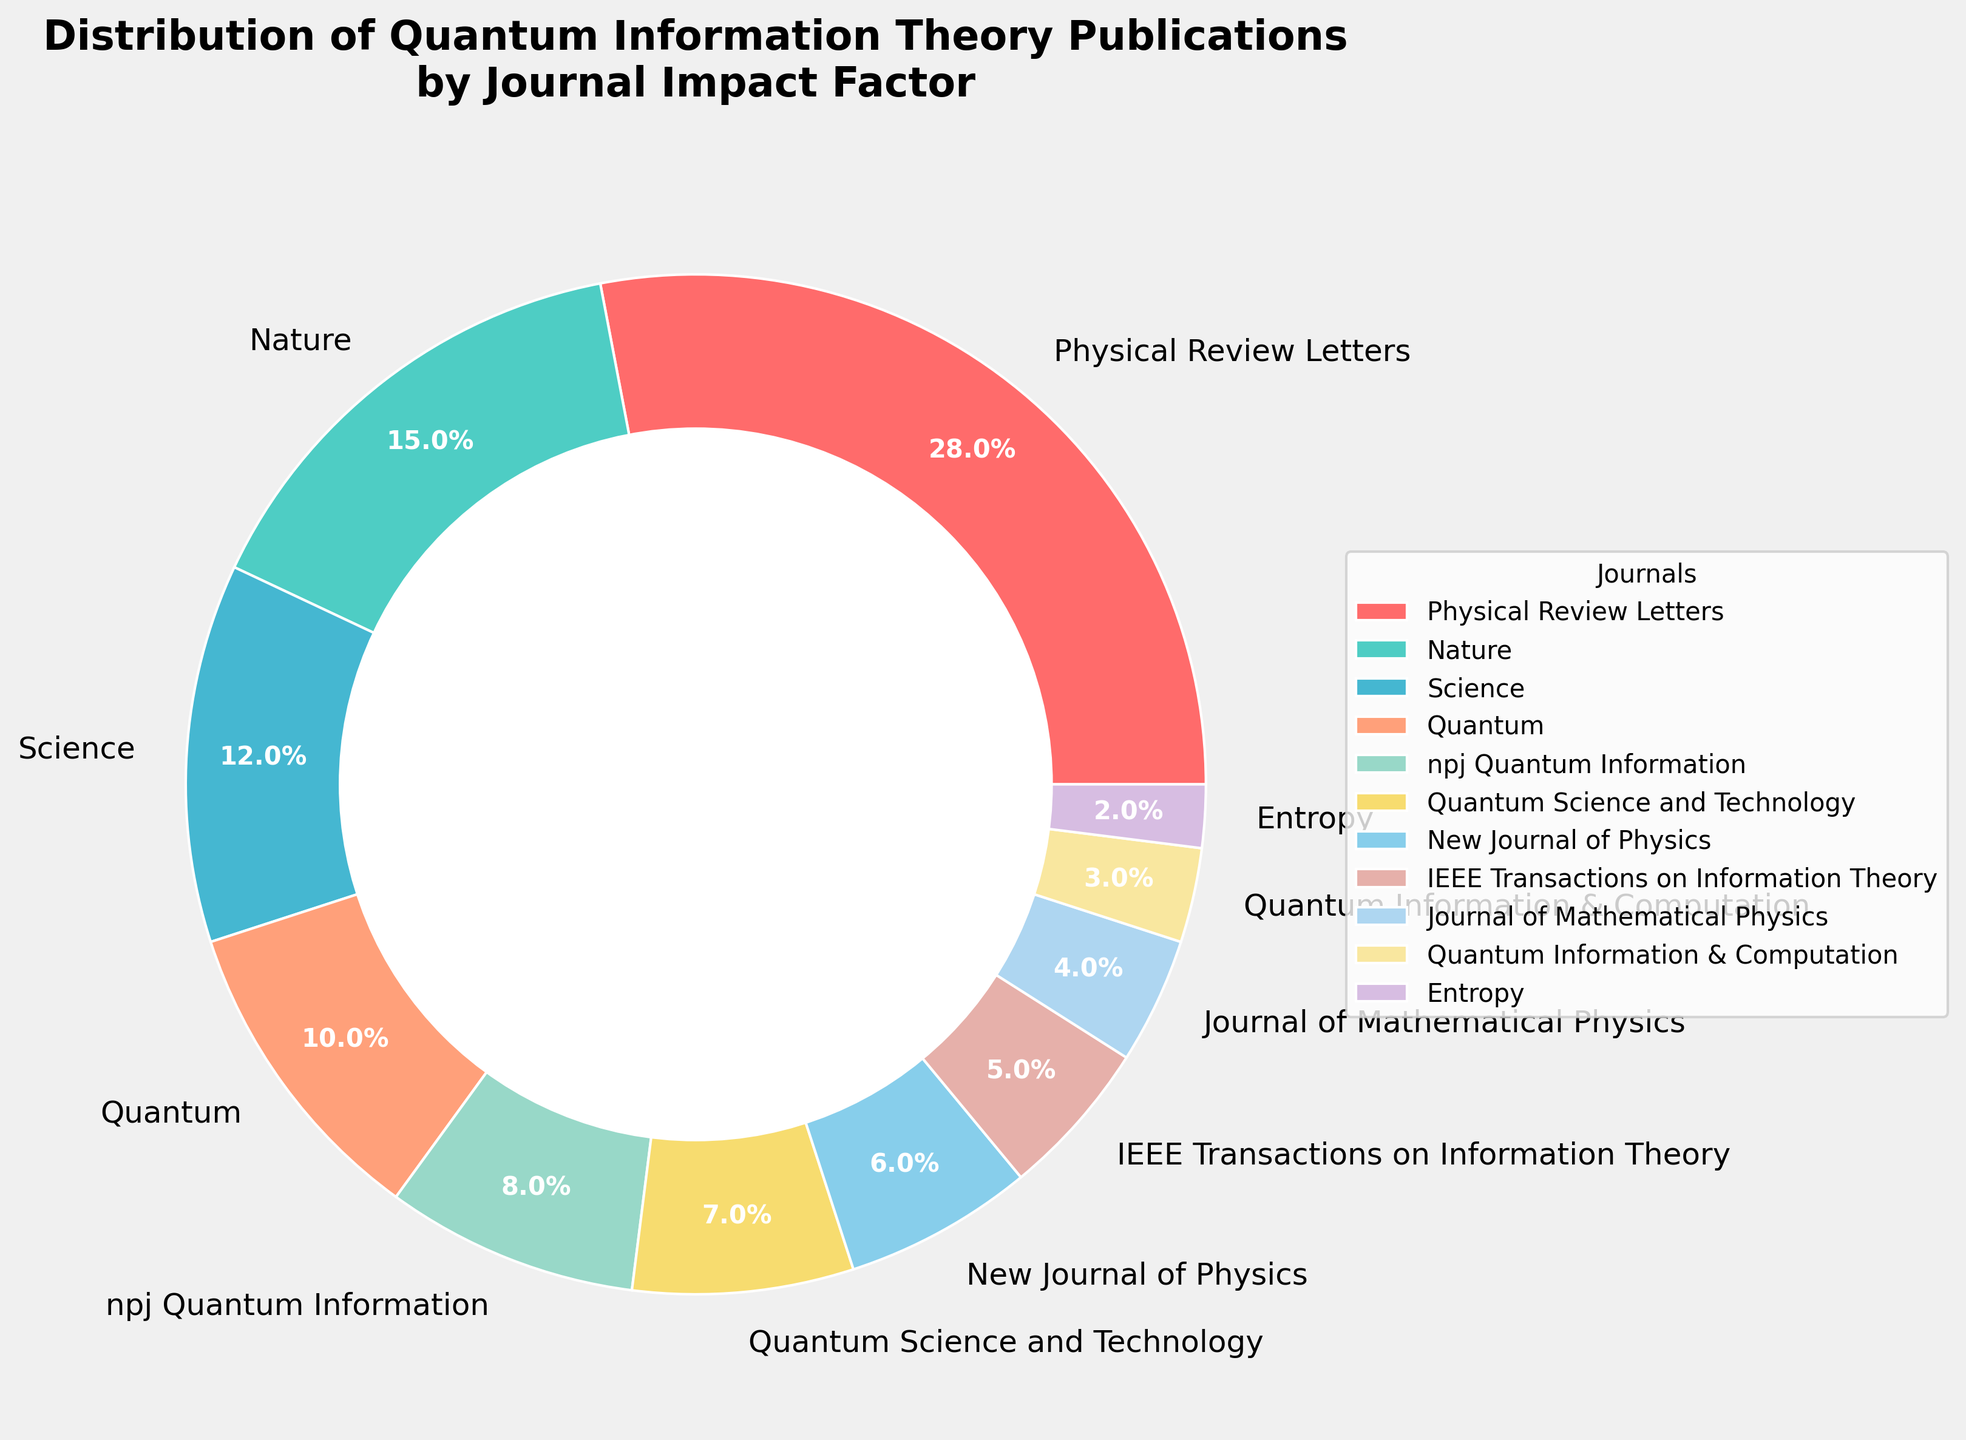What is the percentage of publications in the journal with the highest impact factor? The figure shows different journals and their associated publication percentages. "Physical Review Letters" has the largest slice, corresponding to 28%.
Answer: 28% What is the combined percentage of publications in "Nature" and "Science"? From the chart, "Nature" has 15% and "Science" has 12%. Summing them up gives 15% + 12% = 27%.
Answer: 27% Which journal has the smallest percentage of publications, and what is that percentage? The chart shows "Entropy" with the smallest slice, corresponding to 2%.
Answer: Entropy, 2% How much higher is the percentage of publications in "Physical Review Letters" compared to "Quantum"? "Physical Review Letters" has 28%, and "Quantum" has 10%. The difference is 28% - 10% = 18%.
Answer: 18% Is the percentage of publications in "npj Quantum Information" greater than or less than that in "Quantum"? "npj Quantum Information" has 8%, while "Quantum" has 10%. Therefore, it’s less.
Answer: less What is the total percentage of publications in journals with percentages less than 10% each? Adding up the percentages of "Quantum" (10%), "npj Quantum Information" (8%), "Quantum Science and Technology" (7%), "New Journal of Physics" (6%), "IEEE Transactions on Information Theory" (5%), "Journal of Mathematical Physics" (4%), "Quantum Information & Computation" (3%), "Entropy" (2%) gives: 10% + 8% + 7% + 6% + 5% + 4% + 3% + 2% = 45%.
Answer: 45% Which journal's percentage lies exactly between "Science" and "Quantum Science and Technology" when sorted in ascending order? Sorting the percentages in ascending order, "Quantum Science and Technology" has 7% and "Science" has 12%. The journal between them is "npj Quantum Information" with 8%.
Answer: npj Quantum Information What is the difference between the combined percentage of the top three journals and the bottom three journals? The top three percentages are "Physical Review Letters" (28%), "Nature" (15%), and "Science" (12%), totaling 28% + 15% + 12% = 55%. The bottom three are "Journal of Mathematical Physics" (4%), "Quantum Information & Computation" (3%), and "Entropy" (2%), totaling 4% + 3% + 2% = 9%. The difference is 55% - 9% = 46%.
Answer: 46% Which two journals have a combined percentage very close to the percentage of "Physical Review Letters"? "npj Quantum Information" (8%) and "Quantum Science and Technology" (7%), "New Journal of Physics" (6%) and "IEEE Transactions on Information Theory" (5%) combinations give 8% + 7% = 15%, 6% + 5% = 11%, very far. “Science” (12%) and “Quantum” (10%), summing up to 22%.
Answer: none 